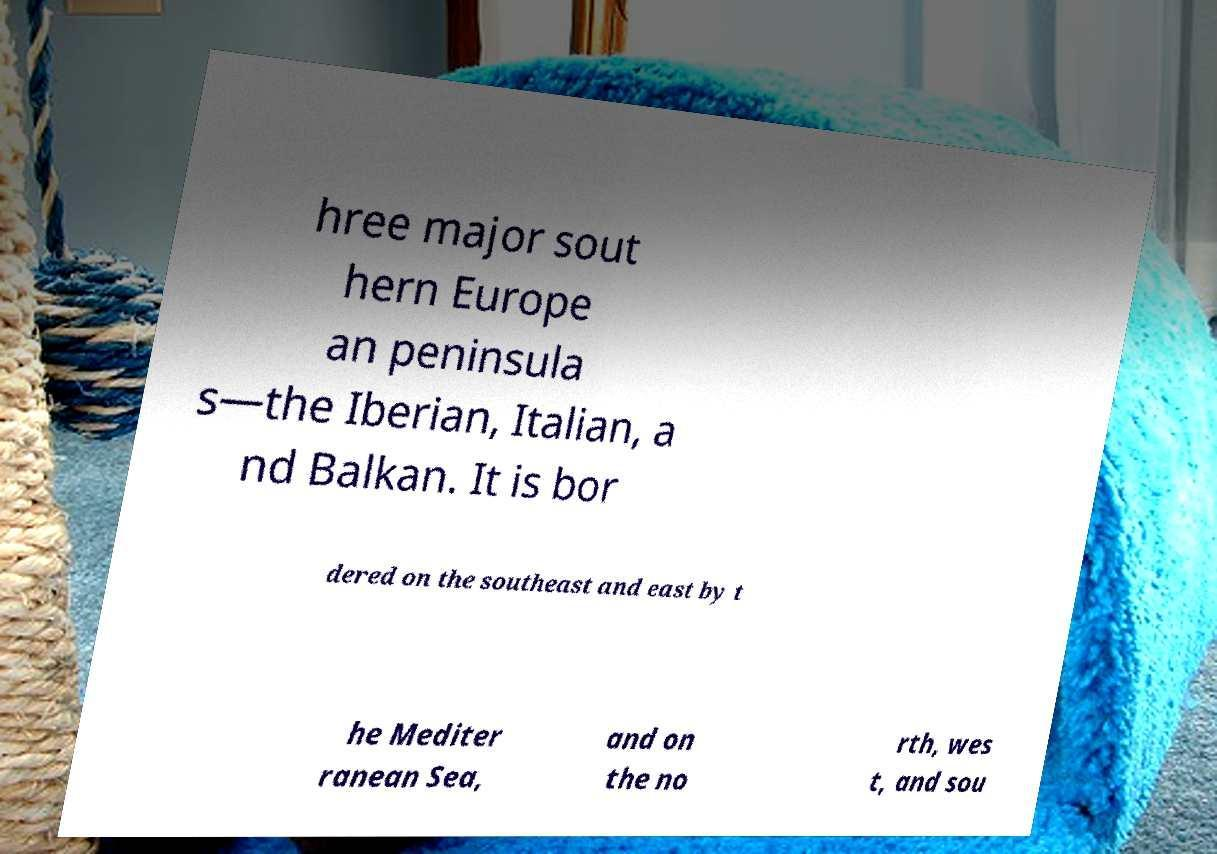Can you read and provide the text displayed in the image?This photo seems to have some interesting text. Can you extract and type it out for me? hree major sout hern Europe an peninsula s—the Iberian, Italian, a nd Balkan. It is bor dered on the southeast and east by t he Mediter ranean Sea, and on the no rth, wes t, and sou 